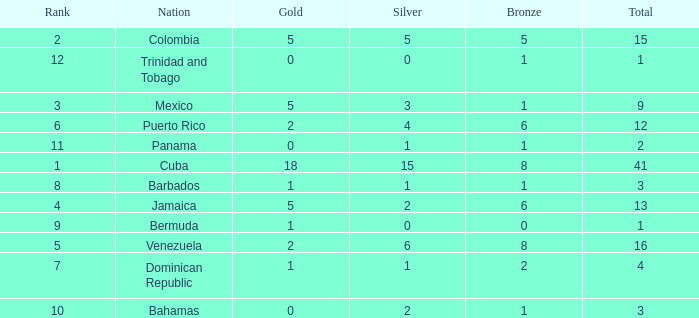Which Total is the lowest one that has a Rank smaller than 1? None. 